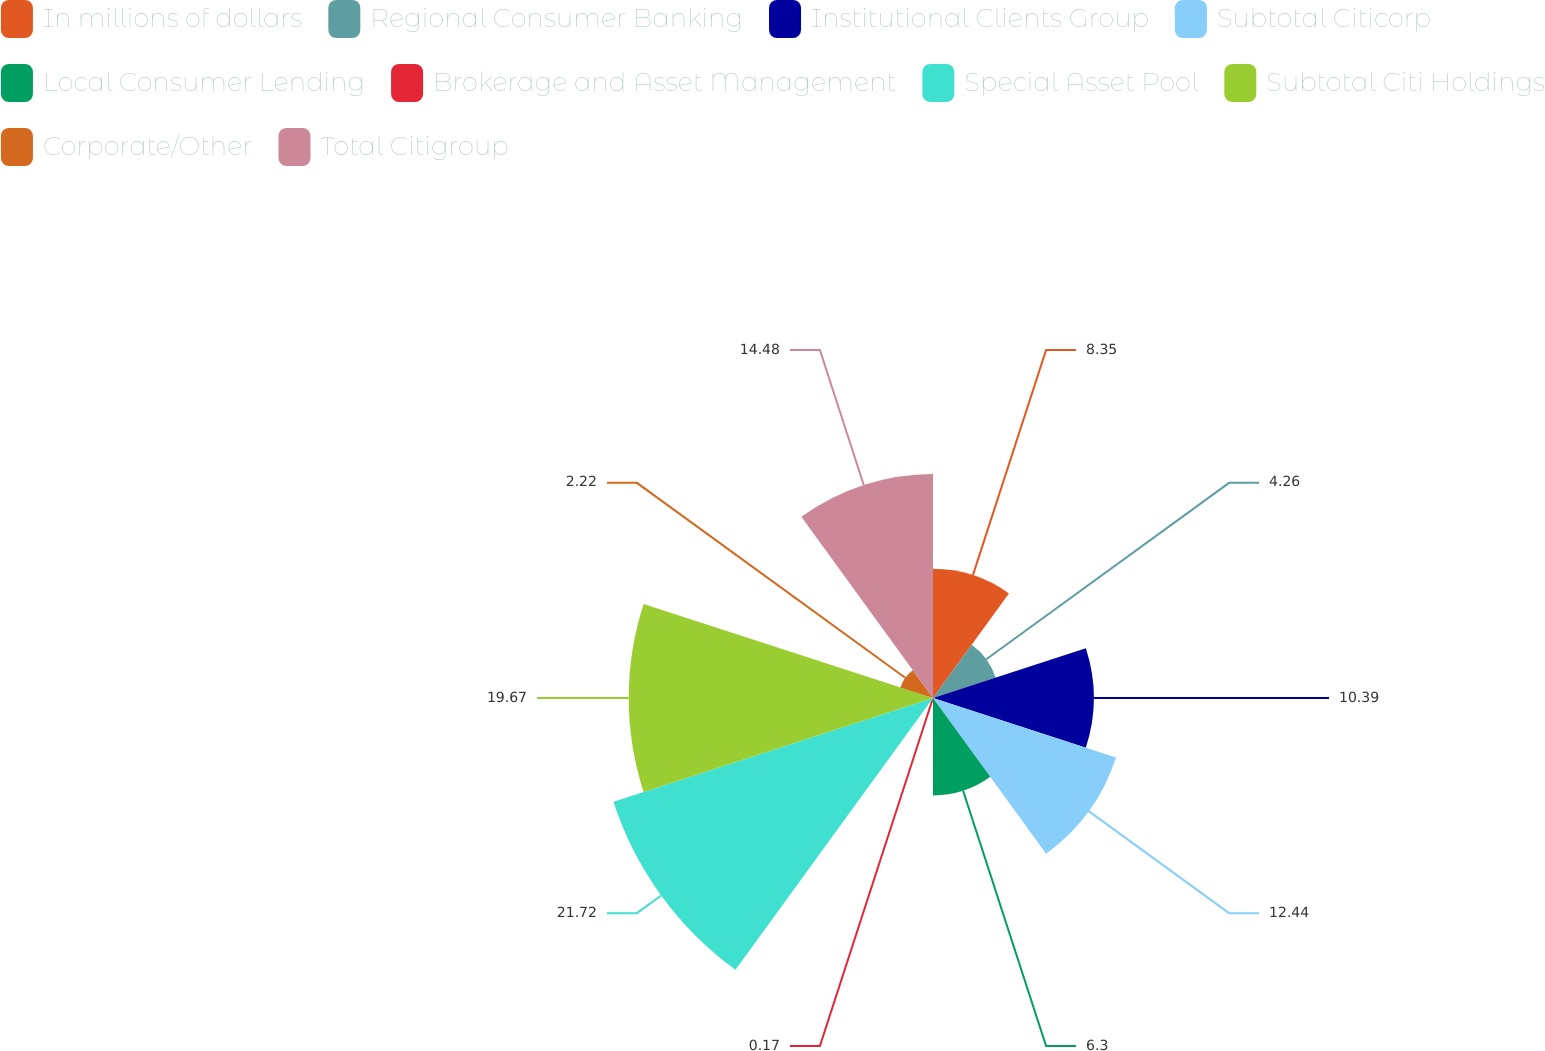Convert chart. <chart><loc_0><loc_0><loc_500><loc_500><pie_chart><fcel>In millions of dollars<fcel>Regional Consumer Banking<fcel>Institutional Clients Group<fcel>Subtotal Citicorp<fcel>Local Consumer Lending<fcel>Brokerage and Asset Management<fcel>Special Asset Pool<fcel>Subtotal Citi Holdings<fcel>Corporate/Other<fcel>Total Citigroup<nl><fcel>8.35%<fcel>4.26%<fcel>10.39%<fcel>12.44%<fcel>6.3%<fcel>0.17%<fcel>21.72%<fcel>19.67%<fcel>2.22%<fcel>14.48%<nl></chart> 